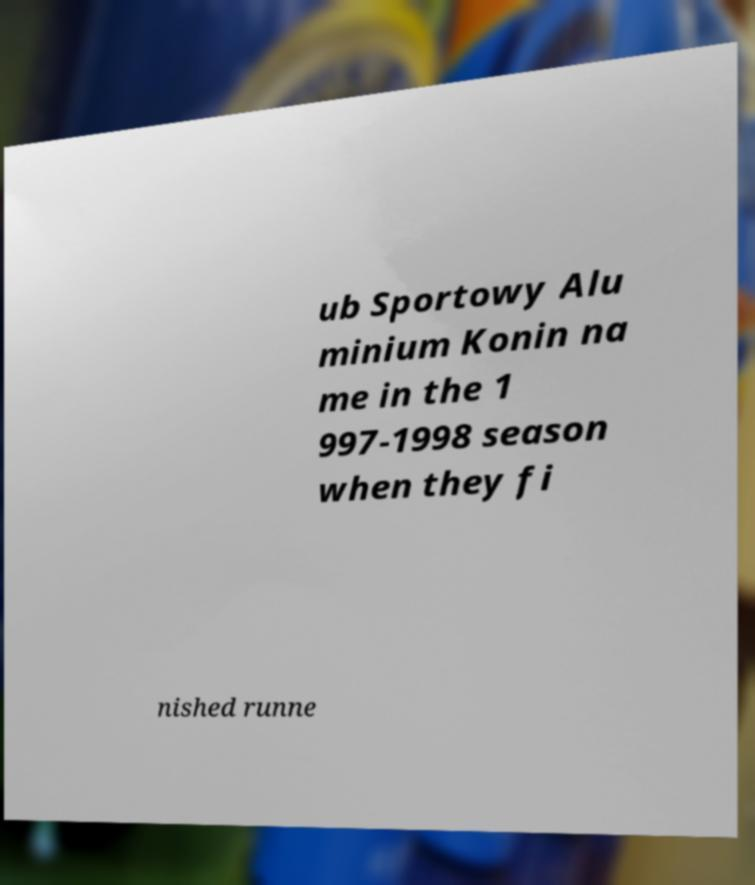Could you extract and type out the text from this image? ub Sportowy Alu minium Konin na me in the 1 997-1998 season when they fi nished runne 